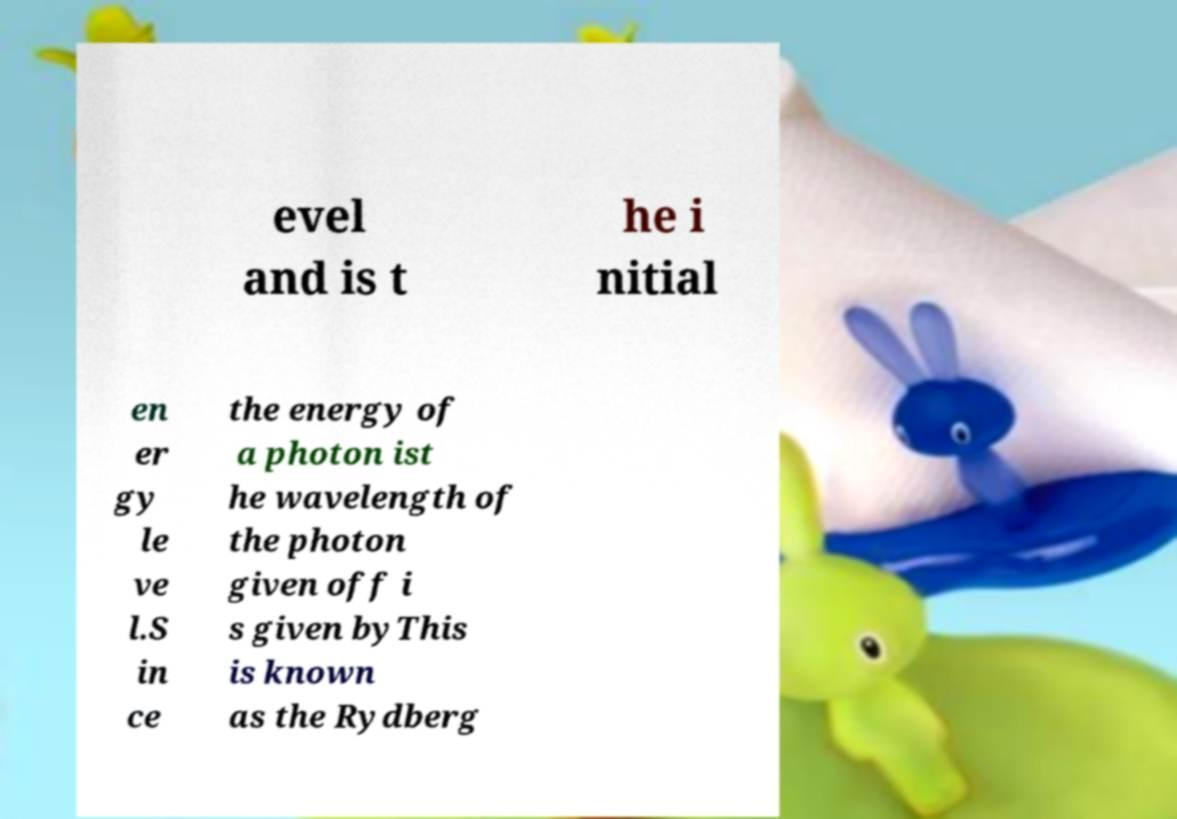Can you accurately transcribe the text from the provided image for me? evel and is t he i nitial en er gy le ve l.S in ce the energy of a photon ist he wavelength of the photon given off i s given byThis is known as the Rydberg 